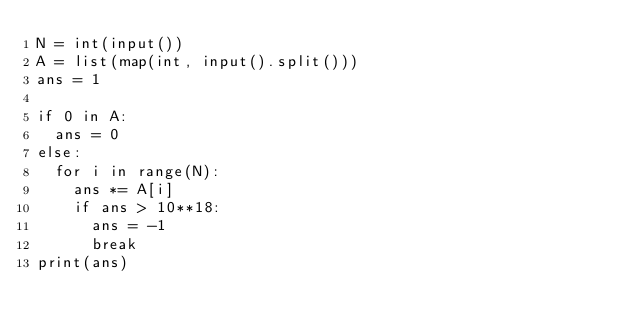Convert code to text. <code><loc_0><loc_0><loc_500><loc_500><_Python_>N = int(input())
A = list(map(int, input().split()))
ans = 1

if 0 in A:
  ans = 0
else:
  for i in range(N):
    ans *= A[i]
    if ans > 10**18:
      ans = -1
      break
print(ans)</code> 